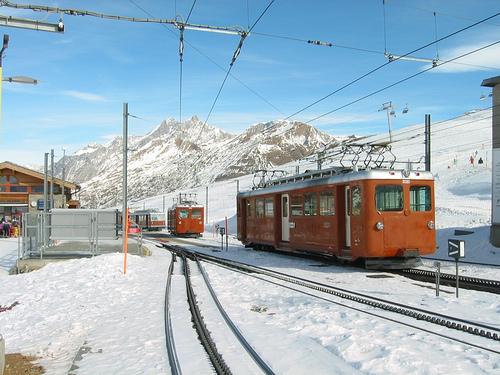Is this a multi-car train?
Give a very brief answer. No. Are there people in the car?
Quick response, please. No. What season is it?
Be succinct. Winter. 